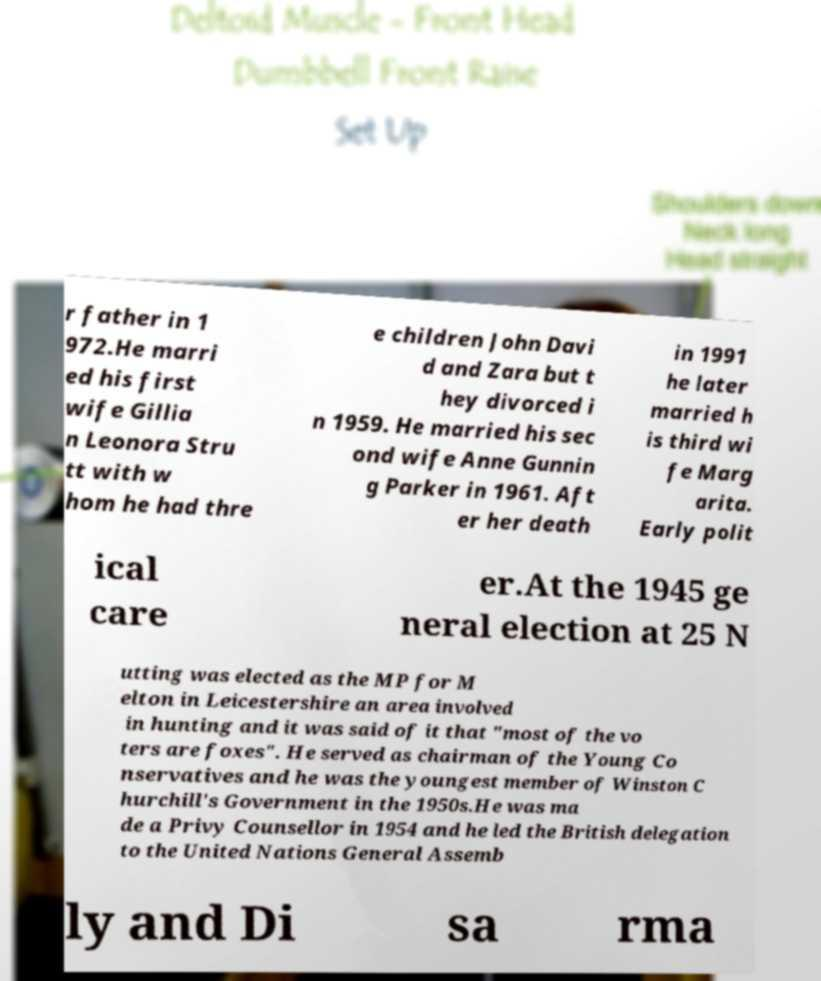There's text embedded in this image that I need extracted. Can you transcribe it verbatim? r father in 1 972.He marri ed his first wife Gillia n Leonora Stru tt with w hom he had thre e children John Davi d and Zara but t hey divorced i n 1959. He married his sec ond wife Anne Gunnin g Parker in 1961. Aft er her death in 1991 he later married h is third wi fe Marg arita. Early polit ical care er.At the 1945 ge neral election at 25 N utting was elected as the MP for M elton in Leicestershire an area involved in hunting and it was said of it that "most of the vo ters are foxes". He served as chairman of the Young Co nservatives and he was the youngest member of Winston C hurchill's Government in the 1950s.He was ma de a Privy Counsellor in 1954 and he led the British delegation to the United Nations General Assemb ly and Di sa rma 